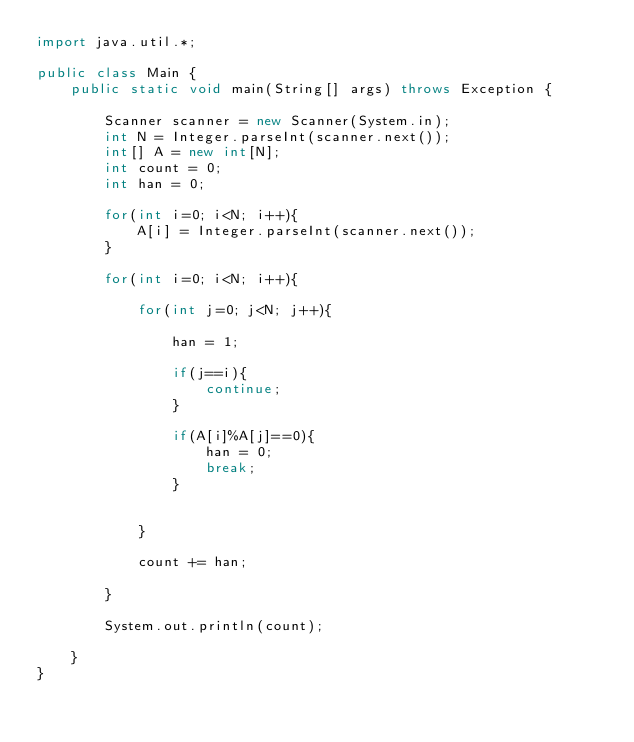Convert code to text. <code><loc_0><loc_0><loc_500><loc_500><_Java_>import java.util.*;

public class Main {
    public static void main(String[] args) throws Exception {
        
        Scanner scanner = new Scanner(System.in);
        int N = Integer.parseInt(scanner.next()); 
        int[] A = new int[N]; 
        int count = 0;
        int han = 0;
        
        for(int i=0; i<N; i++){
            A[i] = Integer.parseInt(scanner.next());
        }
        
        for(int i=0; i<N; i++){
            
            for(int j=0; j<N; j++){
                
                han = 1;
                
                if(j==i){
                    continue;
                }
                
                if(A[i]%A[j]==0){
                    han = 0;
                    break;
                }
                
                
            }
            
            count += han;
            
        }
        
        System.out.println(count);
        
    }
}
</code> 